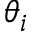<formula> <loc_0><loc_0><loc_500><loc_500>\theta _ { i }</formula> 